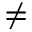<formula> <loc_0><loc_0><loc_500><loc_500>\neq</formula> 